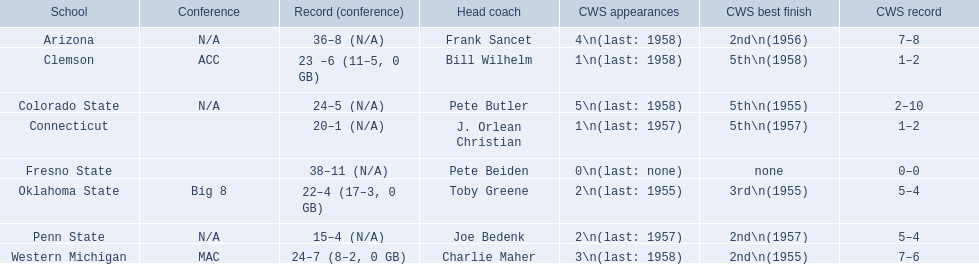What are the groups in the conference? Arizona, Clemson, Colorado State, Connecticut, Fresno State, Oklahoma State, Penn State, Western Michigan. Which have over 16 victories? Arizona, Clemson, Colorado State, Connecticut, Fresno State, Oklahoma State, Western Michigan. Which had fewer than 16 victories? Penn State. 